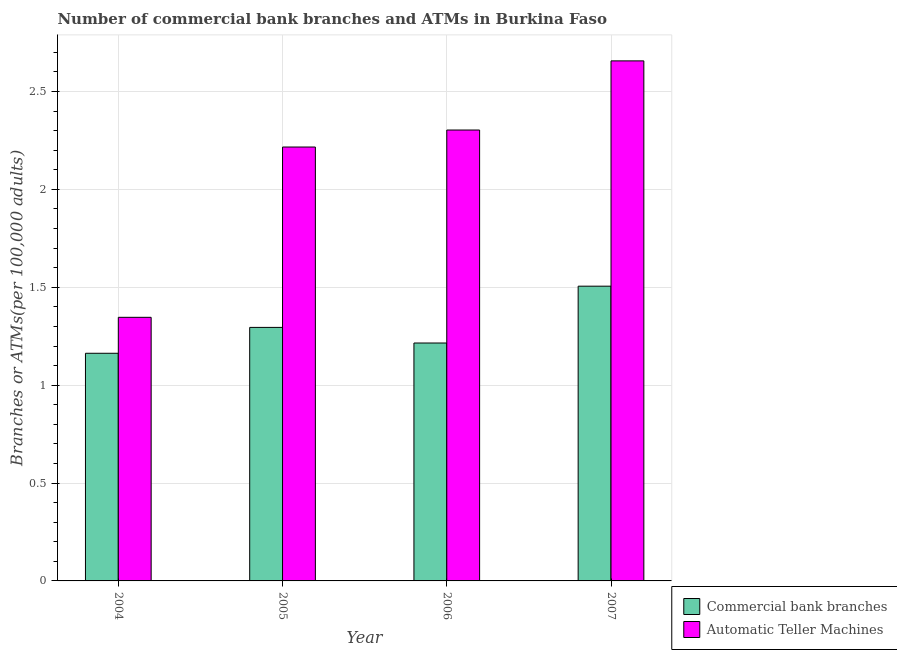How many groups of bars are there?
Your answer should be very brief. 4. Are the number of bars per tick equal to the number of legend labels?
Ensure brevity in your answer.  Yes. How many bars are there on the 3rd tick from the right?
Make the answer very short. 2. What is the number of commercal bank branches in 2006?
Keep it short and to the point. 1.22. Across all years, what is the maximum number of atms?
Ensure brevity in your answer.  2.66. Across all years, what is the minimum number of atms?
Your answer should be compact. 1.35. In which year was the number of atms maximum?
Your answer should be compact. 2007. What is the total number of commercal bank branches in the graph?
Offer a very short reply. 5.18. What is the difference between the number of atms in 2005 and that in 2006?
Provide a succinct answer. -0.09. What is the difference between the number of commercal bank branches in 2005 and the number of atms in 2006?
Your response must be concise. 0.08. What is the average number of commercal bank branches per year?
Ensure brevity in your answer.  1.29. What is the ratio of the number of commercal bank branches in 2004 to that in 2005?
Your answer should be compact. 0.9. Is the number of atms in 2004 less than that in 2005?
Provide a succinct answer. Yes. What is the difference between the highest and the second highest number of atms?
Provide a short and direct response. 0.35. What is the difference between the highest and the lowest number of atms?
Make the answer very short. 1.31. Is the sum of the number of atms in 2004 and 2006 greater than the maximum number of commercal bank branches across all years?
Your answer should be very brief. Yes. What does the 2nd bar from the left in 2006 represents?
Your answer should be very brief. Automatic Teller Machines. What does the 2nd bar from the right in 2006 represents?
Your answer should be compact. Commercial bank branches. How many years are there in the graph?
Offer a very short reply. 4. Are the values on the major ticks of Y-axis written in scientific E-notation?
Your response must be concise. No. Does the graph contain any zero values?
Your answer should be very brief. No. Where does the legend appear in the graph?
Provide a short and direct response. Bottom right. How are the legend labels stacked?
Offer a terse response. Vertical. What is the title of the graph?
Your answer should be compact. Number of commercial bank branches and ATMs in Burkina Faso. What is the label or title of the Y-axis?
Your response must be concise. Branches or ATMs(per 100,0 adults). What is the Branches or ATMs(per 100,000 adults) in Commercial bank branches in 2004?
Give a very brief answer. 1.16. What is the Branches or ATMs(per 100,000 adults) in Automatic Teller Machines in 2004?
Your answer should be very brief. 1.35. What is the Branches or ATMs(per 100,000 adults) of Commercial bank branches in 2005?
Your answer should be compact. 1.3. What is the Branches or ATMs(per 100,000 adults) of Automatic Teller Machines in 2005?
Provide a short and direct response. 2.22. What is the Branches or ATMs(per 100,000 adults) of Commercial bank branches in 2006?
Your answer should be compact. 1.22. What is the Branches or ATMs(per 100,000 adults) in Automatic Teller Machines in 2006?
Your answer should be compact. 2.3. What is the Branches or ATMs(per 100,000 adults) in Commercial bank branches in 2007?
Your answer should be compact. 1.51. What is the Branches or ATMs(per 100,000 adults) in Automatic Teller Machines in 2007?
Your answer should be compact. 2.66. Across all years, what is the maximum Branches or ATMs(per 100,000 adults) of Commercial bank branches?
Make the answer very short. 1.51. Across all years, what is the maximum Branches or ATMs(per 100,000 adults) of Automatic Teller Machines?
Offer a terse response. 2.66. Across all years, what is the minimum Branches or ATMs(per 100,000 adults) in Commercial bank branches?
Make the answer very short. 1.16. Across all years, what is the minimum Branches or ATMs(per 100,000 adults) in Automatic Teller Machines?
Ensure brevity in your answer.  1.35. What is the total Branches or ATMs(per 100,000 adults) of Commercial bank branches in the graph?
Offer a very short reply. 5.18. What is the total Branches or ATMs(per 100,000 adults) of Automatic Teller Machines in the graph?
Offer a very short reply. 8.52. What is the difference between the Branches or ATMs(per 100,000 adults) in Commercial bank branches in 2004 and that in 2005?
Make the answer very short. -0.13. What is the difference between the Branches or ATMs(per 100,000 adults) of Automatic Teller Machines in 2004 and that in 2005?
Make the answer very short. -0.87. What is the difference between the Branches or ATMs(per 100,000 adults) of Commercial bank branches in 2004 and that in 2006?
Provide a succinct answer. -0.05. What is the difference between the Branches or ATMs(per 100,000 adults) in Automatic Teller Machines in 2004 and that in 2006?
Ensure brevity in your answer.  -0.96. What is the difference between the Branches or ATMs(per 100,000 adults) of Commercial bank branches in 2004 and that in 2007?
Offer a very short reply. -0.34. What is the difference between the Branches or ATMs(per 100,000 adults) in Automatic Teller Machines in 2004 and that in 2007?
Ensure brevity in your answer.  -1.31. What is the difference between the Branches or ATMs(per 100,000 adults) of Commercial bank branches in 2005 and that in 2006?
Your answer should be very brief. 0.08. What is the difference between the Branches or ATMs(per 100,000 adults) in Automatic Teller Machines in 2005 and that in 2006?
Ensure brevity in your answer.  -0.09. What is the difference between the Branches or ATMs(per 100,000 adults) in Commercial bank branches in 2005 and that in 2007?
Your response must be concise. -0.21. What is the difference between the Branches or ATMs(per 100,000 adults) of Automatic Teller Machines in 2005 and that in 2007?
Provide a short and direct response. -0.44. What is the difference between the Branches or ATMs(per 100,000 adults) in Commercial bank branches in 2006 and that in 2007?
Your answer should be compact. -0.29. What is the difference between the Branches or ATMs(per 100,000 adults) of Automatic Teller Machines in 2006 and that in 2007?
Offer a terse response. -0.35. What is the difference between the Branches or ATMs(per 100,000 adults) in Commercial bank branches in 2004 and the Branches or ATMs(per 100,000 adults) in Automatic Teller Machines in 2005?
Provide a succinct answer. -1.05. What is the difference between the Branches or ATMs(per 100,000 adults) of Commercial bank branches in 2004 and the Branches or ATMs(per 100,000 adults) of Automatic Teller Machines in 2006?
Your answer should be very brief. -1.14. What is the difference between the Branches or ATMs(per 100,000 adults) in Commercial bank branches in 2004 and the Branches or ATMs(per 100,000 adults) in Automatic Teller Machines in 2007?
Offer a very short reply. -1.49. What is the difference between the Branches or ATMs(per 100,000 adults) of Commercial bank branches in 2005 and the Branches or ATMs(per 100,000 adults) of Automatic Teller Machines in 2006?
Give a very brief answer. -1.01. What is the difference between the Branches or ATMs(per 100,000 adults) of Commercial bank branches in 2005 and the Branches or ATMs(per 100,000 adults) of Automatic Teller Machines in 2007?
Provide a short and direct response. -1.36. What is the difference between the Branches or ATMs(per 100,000 adults) in Commercial bank branches in 2006 and the Branches or ATMs(per 100,000 adults) in Automatic Teller Machines in 2007?
Give a very brief answer. -1.44. What is the average Branches or ATMs(per 100,000 adults) of Commercial bank branches per year?
Make the answer very short. 1.29. What is the average Branches or ATMs(per 100,000 adults) of Automatic Teller Machines per year?
Give a very brief answer. 2.13. In the year 2004, what is the difference between the Branches or ATMs(per 100,000 adults) of Commercial bank branches and Branches or ATMs(per 100,000 adults) of Automatic Teller Machines?
Give a very brief answer. -0.18. In the year 2005, what is the difference between the Branches or ATMs(per 100,000 adults) in Commercial bank branches and Branches or ATMs(per 100,000 adults) in Automatic Teller Machines?
Your answer should be compact. -0.92. In the year 2006, what is the difference between the Branches or ATMs(per 100,000 adults) of Commercial bank branches and Branches or ATMs(per 100,000 adults) of Automatic Teller Machines?
Your answer should be compact. -1.09. In the year 2007, what is the difference between the Branches or ATMs(per 100,000 adults) in Commercial bank branches and Branches or ATMs(per 100,000 adults) in Automatic Teller Machines?
Your answer should be compact. -1.15. What is the ratio of the Branches or ATMs(per 100,000 adults) in Commercial bank branches in 2004 to that in 2005?
Your answer should be very brief. 0.9. What is the ratio of the Branches or ATMs(per 100,000 adults) of Automatic Teller Machines in 2004 to that in 2005?
Provide a short and direct response. 0.61. What is the ratio of the Branches or ATMs(per 100,000 adults) of Commercial bank branches in 2004 to that in 2006?
Offer a terse response. 0.96. What is the ratio of the Branches or ATMs(per 100,000 adults) of Automatic Teller Machines in 2004 to that in 2006?
Keep it short and to the point. 0.58. What is the ratio of the Branches or ATMs(per 100,000 adults) in Commercial bank branches in 2004 to that in 2007?
Your answer should be compact. 0.77. What is the ratio of the Branches or ATMs(per 100,000 adults) of Automatic Teller Machines in 2004 to that in 2007?
Ensure brevity in your answer.  0.51. What is the ratio of the Branches or ATMs(per 100,000 adults) in Commercial bank branches in 2005 to that in 2006?
Give a very brief answer. 1.07. What is the ratio of the Branches or ATMs(per 100,000 adults) in Automatic Teller Machines in 2005 to that in 2006?
Ensure brevity in your answer.  0.96. What is the ratio of the Branches or ATMs(per 100,000 adults) of Commercial bank branches in 2005 to that in 2007?
Keep it short and to the point. 0.86. What is the ratio of the Branches or ATMs(per 100,000 adults) of Automatic Teller Machines in 2005 to that in 2007?
Provide a short and direct response. 0.83. What is the ratio of the Branches or ATMs(per 100,000 adults) of Commercial bank branches in 2006 to that in 2007?
Provide a succinct answer. 0.81. What is the ratio of the Branches or ATMs(per 100,000 adults) of Automatic Teller Machines in 2006 to that in 2007?
Keep it short and to the point. 0.87. What is the difference between the highest and the second highest Branches or ATMs(per 100,000 adults) of Commercial bank branches?
Provide a succinct answer. 0.21. What is the difference between the highest and the second highest Branches or ATMs(per 100,000 adults) of Automatic Teller Machines?
Your answer should be compact. 0.35. What is the difference between the highest and the lowest Branches or ATMs(per 100,000 adults) of Commercial bank branches?
Ensure brevity in your answer.  0.34. What is the difference between the highest and the lowest Branches or ATMs(per 100,000 adults) of Automatic Teller Machines?
Give a very brief answer. 1.31. 